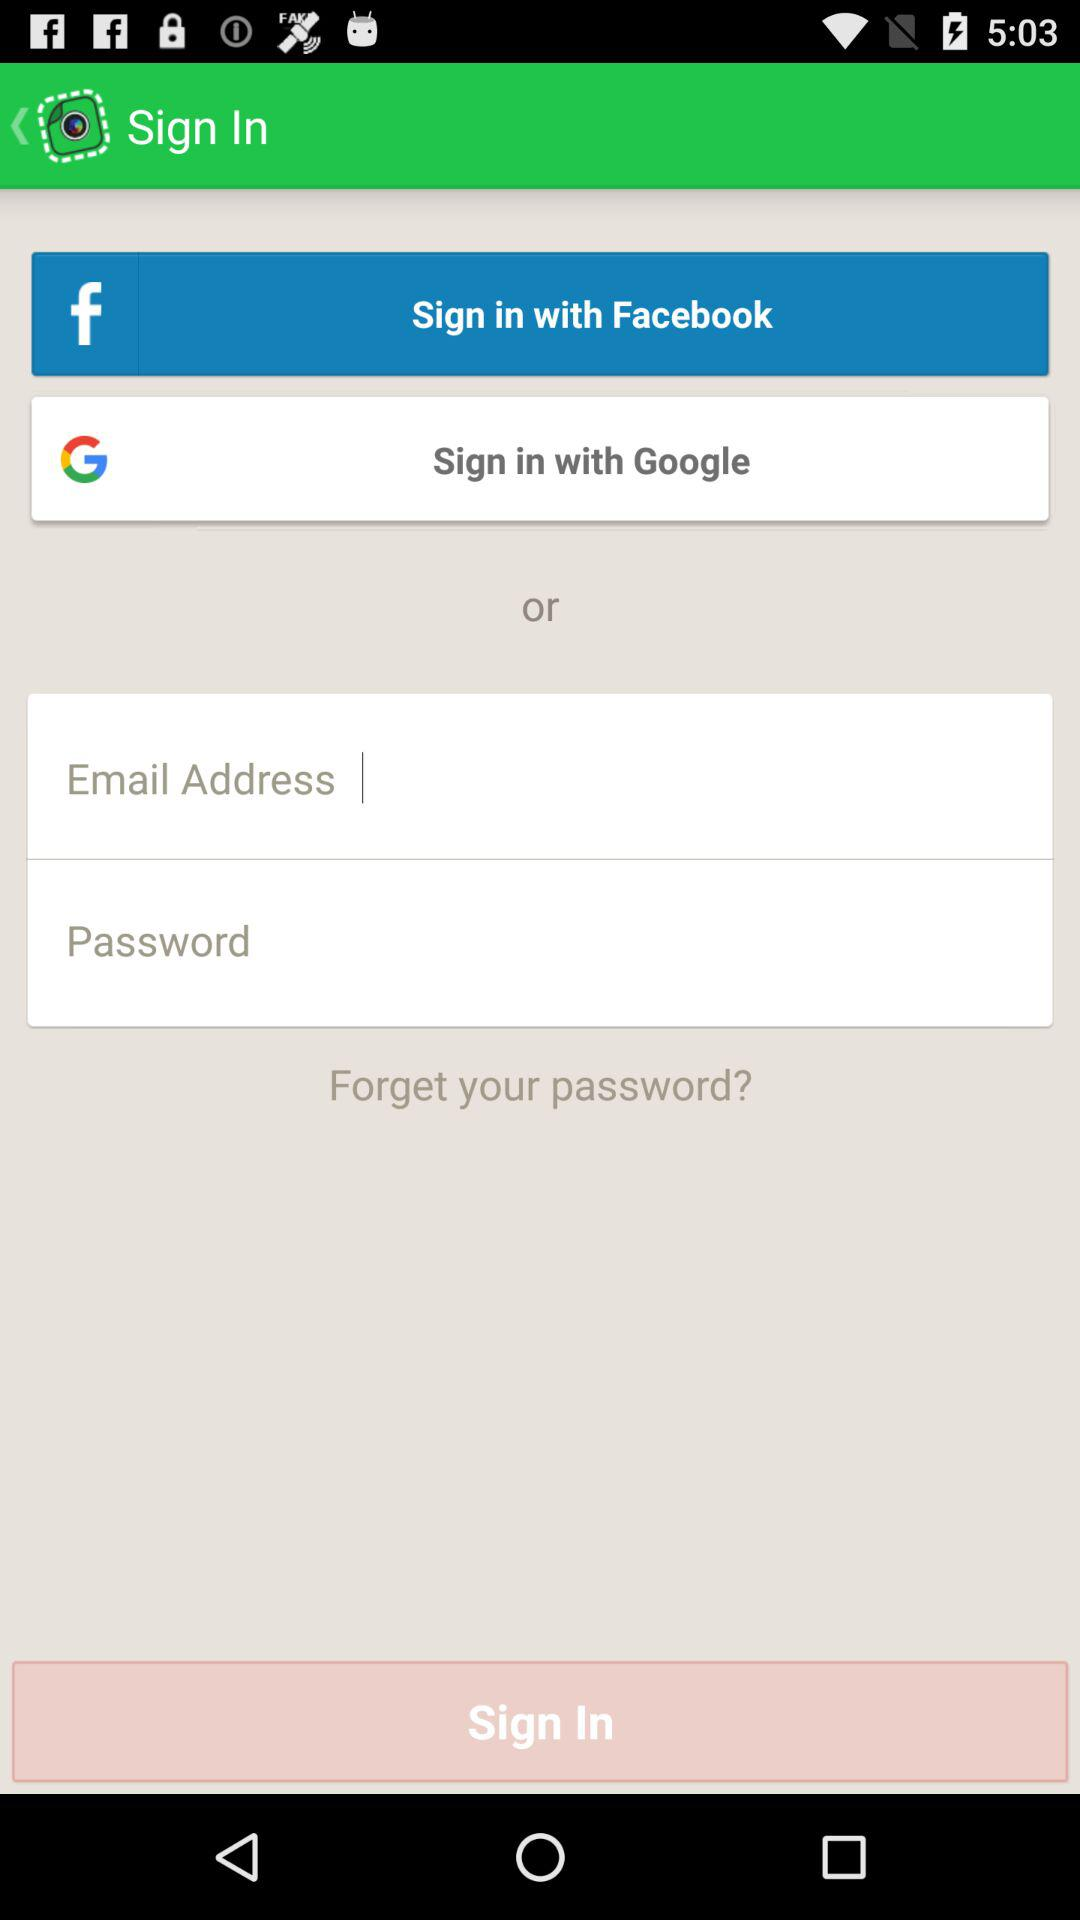What applications can be used to login to a profile? The applications that can be used to login are "Facebook" and "Google". 